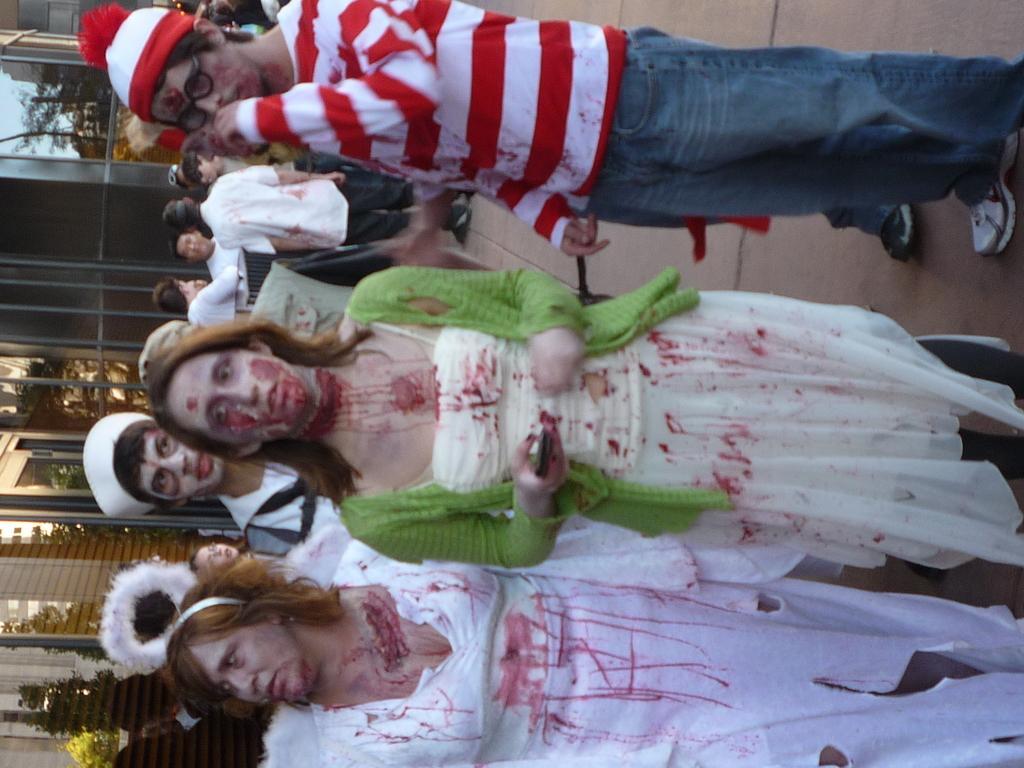Describe this image in one or two sentences. This picture is clicked outside. In the center we can see the group of people standing on the ground. In the background there is a sky, trees and buildings. 